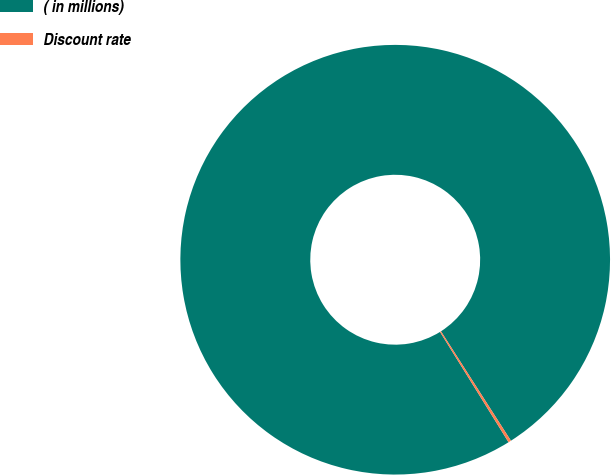Convert chart. <chart><loc_0><loc_0><loc_500><loc_500><pie_chart><fcel>( in millions)<fcel>Discount rate<nl><fcel>99.79%<fcel>0.21%<nl></chart> 